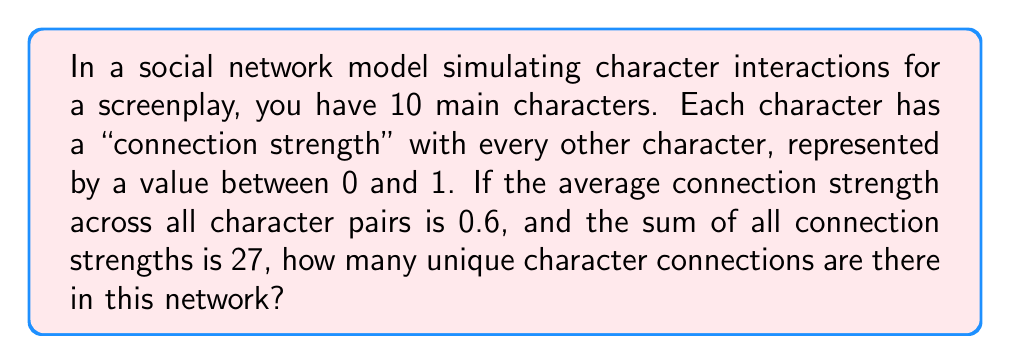Give your solution to this math problem. Let's approach this step-by-step:

1) First, we need to calculate the total number of possible connections in a network of 10 characters. This is given by the combination formula:

   $$\binom{10}{2} = \frac{10!}{2!(10-2)!} = \frac{10 \cdot 9}{2} = 45$$

2) Now, we know that the sum of all connection strengths is 27, and the average connection strength is 0.6.

3) Let $x$ be the number of actual connections. We can set up an equation:

   $$\frac{27}{x} = 0.6$$

4) Solving for $x$:

   $$x = \frac{27}{0.6} = 45$$

5) This result matches the total number of possible connections we calculated in step 1, which means all possible connections are present in the network.
Answer: 45 connections 